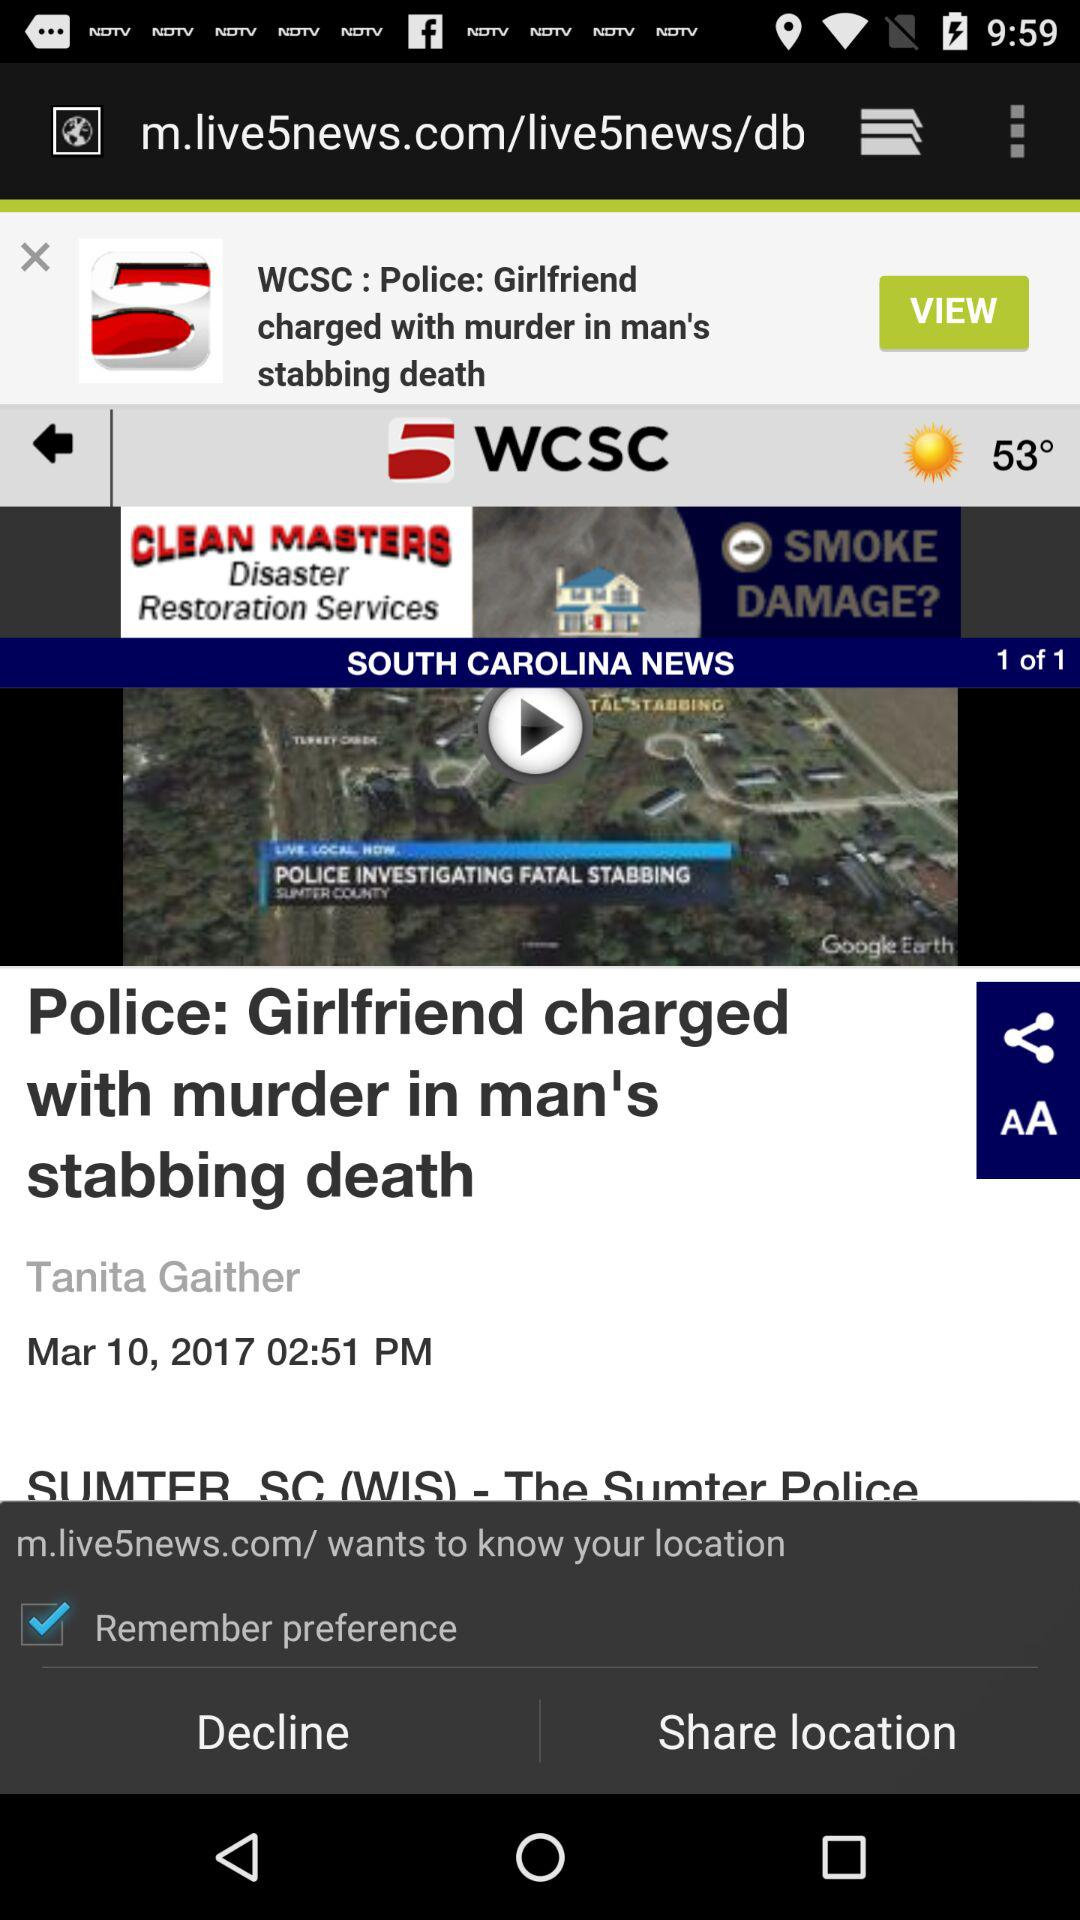Who is the author of the article? The author of the article is Tanita Gaither. 